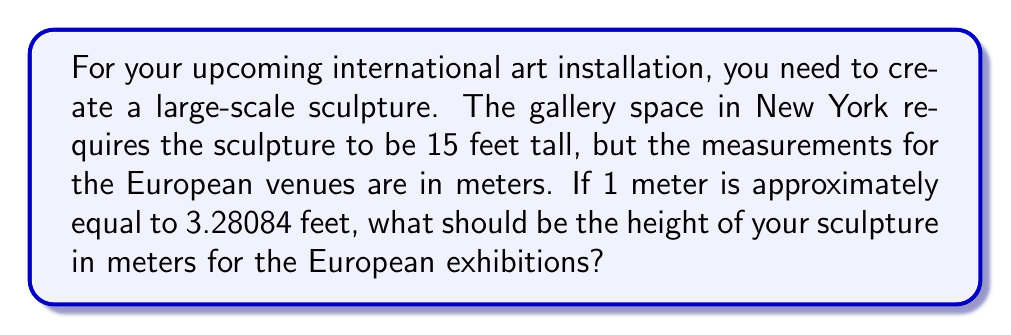Give your solution to this math problem. To solve this problem, we need to convert 15 feet to meters. We can use the given conversion factor: 1 meter ≈ 3.28084 feet.

Let's set up the conversion:

$$\frac{15 \text{ feet}}{x \text{ meters}} = \frac{3.28084 \text{ feet}}{1 \text{ meter}}$$

Cross-multiply:

$$15 \cdot 1 = 3.28084x$$

Solve for $x$:

$$x = \frac{15}{3.28084}$$

Using a calculator:

$$x \approx 4.5720 \text{ meters}$$

Rounding to two decimal places for practical measurement:

$$x \approx 4.57 \text{ meters}$$

Therefore, the sculpture should be approximately 4.57 meters tall for the European exhibitions.
Answer: $4.57 \text{ m}$ 